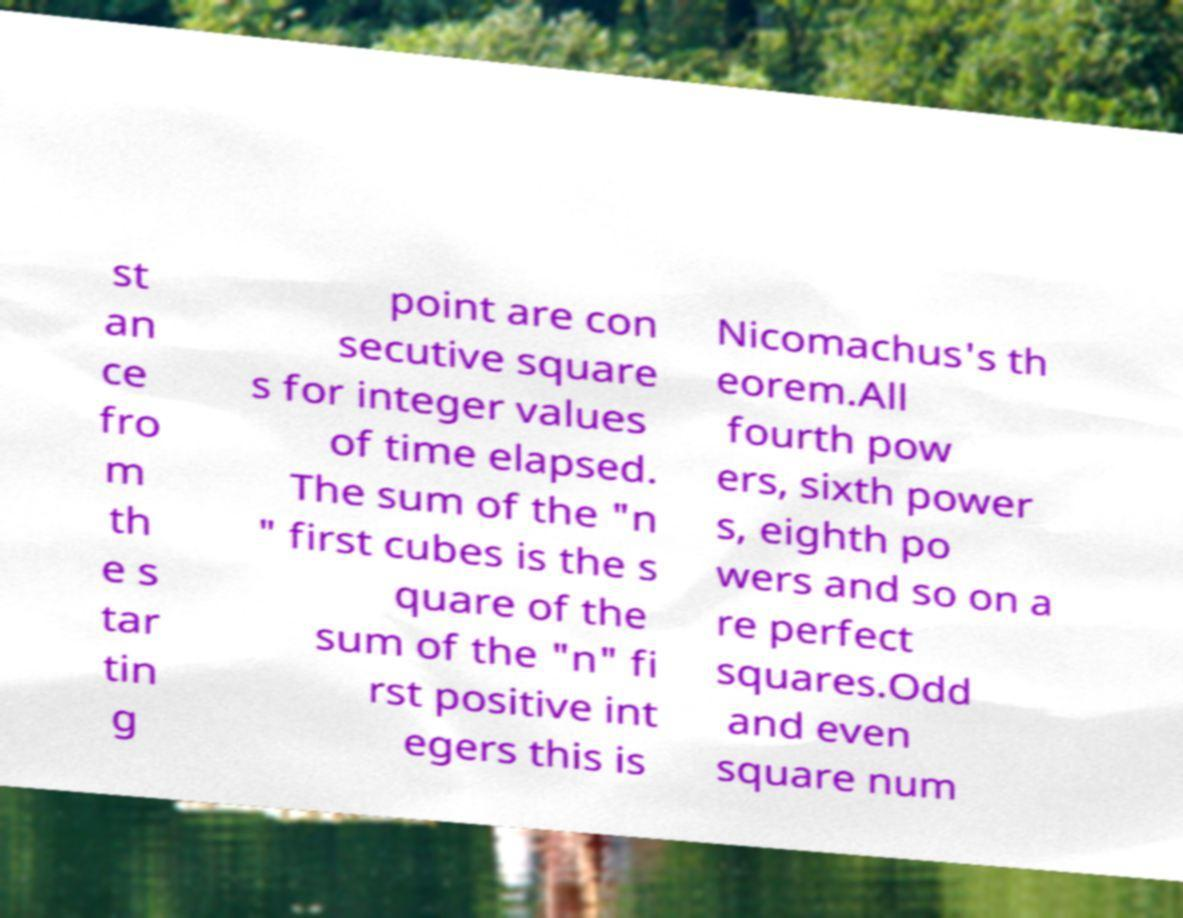What messages or text are displayed in this image? I need them in a readable, typed format. st an ce fro m th e s tar tin g point are con secutive square s for integer values of time elapsed. The sum of the "n " first cubes is the s quare of the sum of the "n" fi rst positive int egers this is Nicomachus's th eorem.All fourth pow ers, sixth power s, eighth po wers and so on a re perfect squares.Odd and even square num 